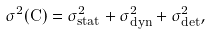<formula> <loc_0><loc_0><loc_500><loc_500>\sigma ^ { 2 } ( C ) = \sigma ^ { 2 } _ { s t a t } + \sigma ^ { 2 } _ { d y n } + \sigma ^ { 2 } _ { d e t } ,</formula> 